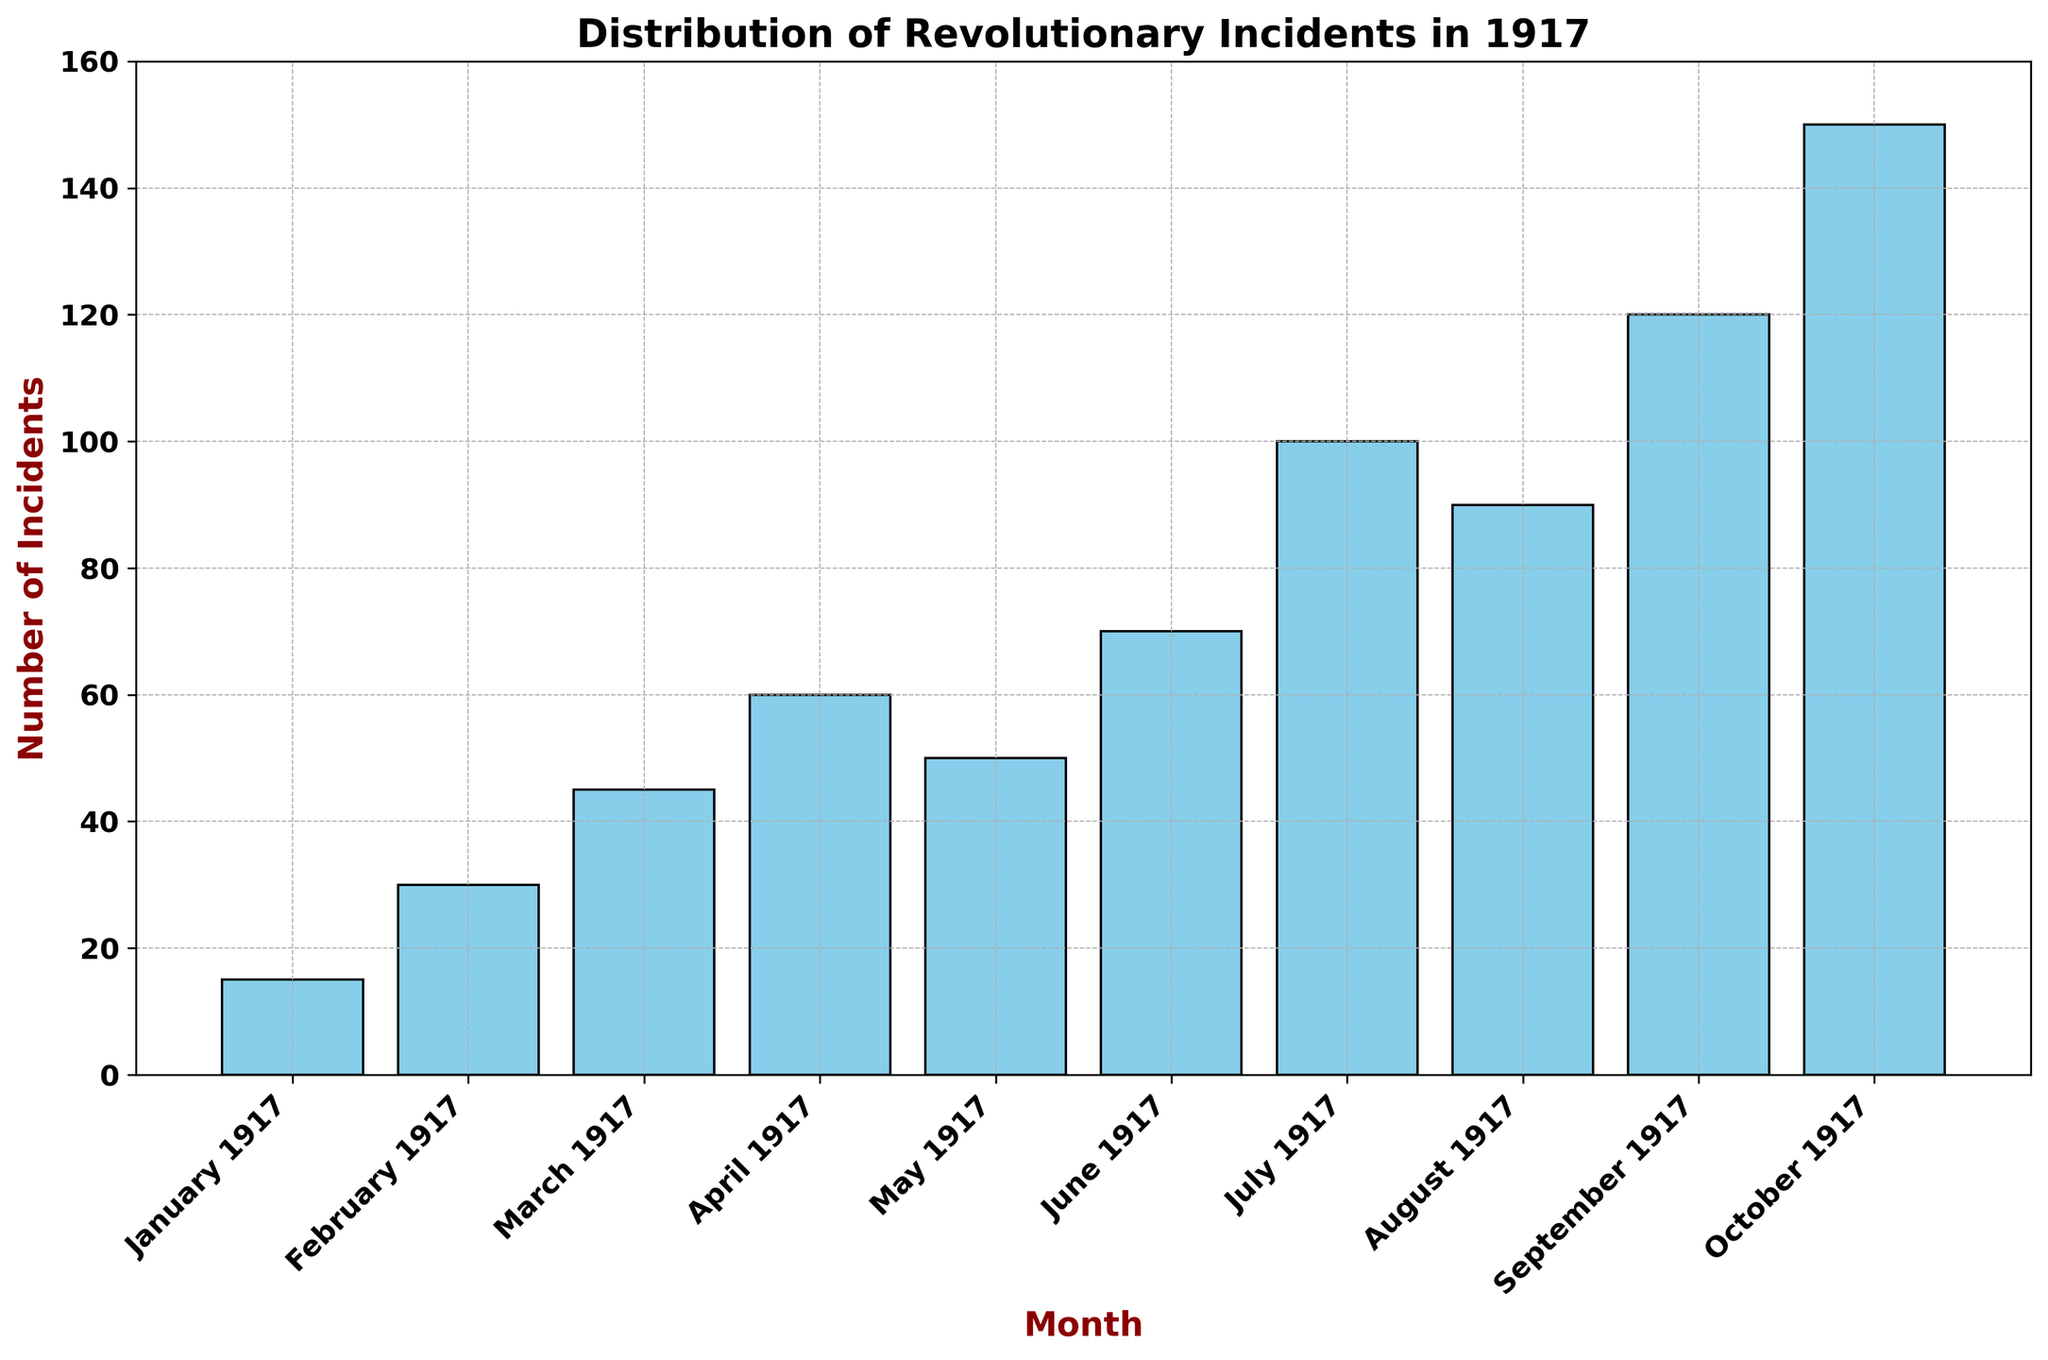What is the highest number of incidents recorded in a single month? The highest bar in the histogram represents October 1917, which has 150 incidents. This can be identified by looking at the height comparing to other bars.
Answer: 150 Which month saw the smallest number of incidents? The shortest bar on the chart corresponds to January 1917, which has the smallest number of incidents. This can be identified as the lowest value on the y-axis for the respective month.
Answer: January 1917 How does the number of incidents in March 1917 compare to those in May 1917? March 1917 has 45 incidents, and May 1917 has 50 incidents. To compare, 45 is less than 50, so March had fewer incidents than May.
Answer: March had fewer incidents than May What is the combined total of incidents for the first quarter of 1917 (January, February, March)? Adding the number of incidents for January (15), February (30), and March (45): \(15 + 30 + 45 = 90\).
Answer: 90 In which month did the number of incidents first surpass 70? The histogram reveals that July 1917 is the first month where the bar's height surpasses the 70 incidents mark, with 100 incidents recorded.
Answer: July 1917 How many more incidents were recorded in September compared to April 1917? September 1917 has 120 incidents, and April 1917 has 60 incidents. The difference is calculated as \(120 - 60 = 60\).
Answer: 60 Compare the trend of incidents from January to June 1917. Is there a general increase or decrease, and by how much does it change by the end of June? From January (15) to June (70), the incidents generally increase. The change is \(70 - 15 = 55\). This shows a growing trend over the months.
Answer: Increase by 55 What is the average number of incidents per month in the third quarter of 1917 (July, August, September)? Summing the number of incidents for July, August, and September gives: \(100 + 90 + 120 = 310\). There are 3 months, so dividing the total by 3 gives: \(310 / 3 \approx 103.33\).
Answer: Approximately 103.33 Which months had an incident count above the median value, and what is that median? Ordering the incidents: [15, 30, 45, 50, 60, 70, 90, 100, 120, 150], the median falls between 60 and 70. Hence, the median is \( (60 + 70) / 2 = 65 \). Months with incidents above 65 are June, July, August, September, and October 1917.
Answer: June, July, August, September, October 1917, and the median is 65 